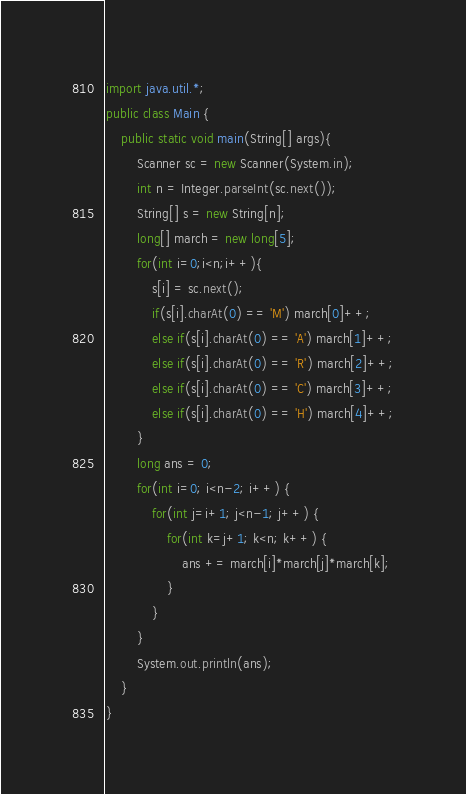<code> <loc_0><loc_0><loc_500><loc_500><_Java_>import java.util.*;
public class Main {
	public static void main(String[] args){
		Scanner sc = new Scanner(System.in);       
		int n = Integer.parseInt(sc.next());
		String[] s = new String[n];
		long[] march = new long[5];
        for(int i=0;i<n;i++){
            s[i] = sc.next();
            if(s[i].charAt(0) == 'M') march[0]++;
            else if(s[i].charAt(0) == 'A') march[1]++;
            else if(s[i].charAt(0) == 'R') march[2]++;
            else if(s[i].charAt(0) == 'C') march[3]++;
            else if(s[i].charAt(0) == 'H') march[4]++;
        }
        long ans = 0;
        for(int i=0; i<n-2; i++) {
            for(int j=i+1; j<n-1; j++) {
                for(int k=j+1; k<n; k++) {
                    ans += march[i]*march[j]*march[k];
                }
            }
        }
        System.out.println(ans);
	}
}</code> 